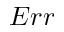<formula> <loc_0><loc_0><loc_500><loc_500>E r r</formula> 